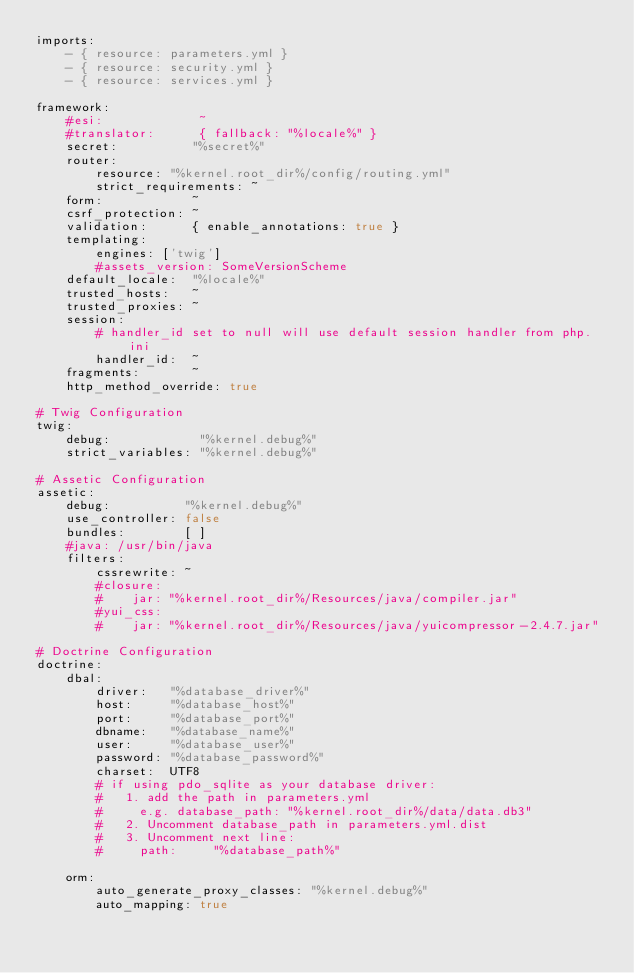<code> <loc_0><loc_0><loc_500><loc_500><_YAML_>imports:
    - { resource: parameters.yml }
    - { resource: security.yml }
    - { resource: services.yml }

framework:
    #esi:             ~
    #translator:      { fallback: "%locale%" }
    secret:          "%secret%"
    router:
        resource: "%kernel.root_dir%/config/routing.yml"
        strict_requirements: ~
    form:            ~
    csrf_protection: ~
    validation:      { enable_annotations: true }
    templating:
        engines: ['twig']
        #assets_version: SomeVersionScheme
    default_locale:  "%locale%"
    trusted_hosts:   ~
    trusted_proxies: ~
    session:
        # handler_id set to null will use default session handler from php.ini
        handler_id:  ~
    fragments:       ~
    http_method_override: true

# Twig Configuration
twig:
    debug:            "%kernel.debug%"
    strict_variables: "%kernel.debug%"

# Assetic Configuration
assetic:
    debug:          "%kernel.debug%"
    use_controller: false
    bundles:        [ ]
    #java: /usr/bin/java
    filters:
        cssrewrite: ~
        #closure:
        #    jar: "%kernel.root_dir%/Resources/java/compiler.jar"
        #yui_css:
        #    jar: "%kernel.root_dir%/Resources/java/yuicompressor-2.4.7.jar"

# Doctrine Configuration
doctrine:
    dbal:
        driver:   "%database_driver%"
        host:     "%database_host%"
        port:     "%database_port%"
        dbname:   "%database_name%"
        user:     "%database_user%"
        password: "%database_password%"
        charset:  UTF8
        # if using pdo_sqlite as your database driver:
        #   1. add the path in parameters.yml
        #     e.g. database_path: "%kernel.root_dir%/data/data.db3"
        #   2. Uncomment database_path in parameters.yml.dist
        #   3. Uncomment next line:
        #     path:     "%database_path%"

    orm:
        auto_generate_proxy_classes: "%kernel.debug%"
        auto_mapping: true</code> 